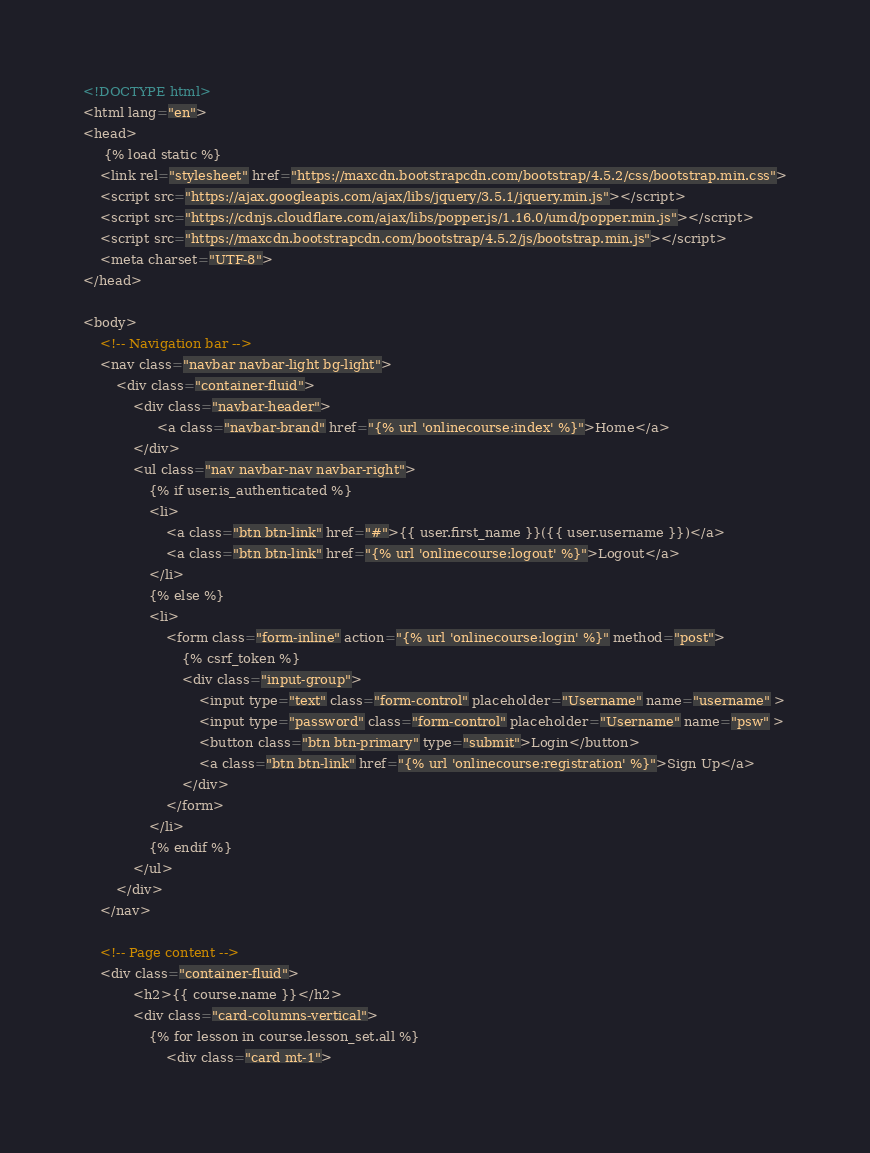<code> <loc_0><loc_0><loc_500><loc_500><_HTML_><!DOCTYPE html>
<html lang="en">
<head>
     {% load static %}
    <link rel="stylesheet" href="https://maxcdn.bootstrapcdn.com/bootstrap/4.5.2/css/bootstrap.min.css">
    <script src="https://ajax.googleapis.com/ajax/libs/jquery/3.5.1/jquery.min.js"></script>
    <script src="https://cdnjs.cloudflare.com/ajax/libs/popper.js/1.16.0/umd/popper.min.js"></script>
    <script src="https://maxcdn.bootstrapcdn.com/bootstrap/4.5.2/js/bootstrap.min.js"></script>
    <meta charset="UTF-8">
</head>

<body>
    <!-- Navigation bar -->
    <nav class="navbar navbar-light bg-light">
        <div class="container-fluid">
            <div class="navbar-header">
                  <a class="navbar-brand" href="{% url 'onlinecourse:index' %}">Home</a>
            </div>
            <ul class="nav navbar-nav navbar-right">
                {% if user.is_authenticated %}
                <li>
                    <a class="btn btn-link" href="#">{{ user.first_name }}({{ user.username }})</a>
                    <a class="btn btn-link" href="{% url 'onlinecourse:logout' %}">Logout</a>
                </li>
                {% else %}
                <li>
                    <form class="form-inline" action="{% url 'onlinecourse:login' %}" method="post">
                        {% csrf_token %}
                        <div class="input-group">
                            <input type="text" class="form-control" placeholder="Username" name="username" >
                            <input type="password" class="form-control" placeholder="Username" name="psw" >
                            <button class="btn btn-primary" type="submit">Login</button>
                            <a class="btn btn-link" href="{% url 'onlinecourse:registration' %}">Sign Up</a>
                        </div>
                    </form>
                </li>
                {% endif %}
            </ul>
        </div>
    </nav>

    <!-- Page content -->
    <div class="container-fluid">
            <h2>{{ course.name }}</h2>
            <div class="card-columns-vertical">
                {% for lesson in course.lesson_set.all %}
                    <div class="card mt-1"></code> 